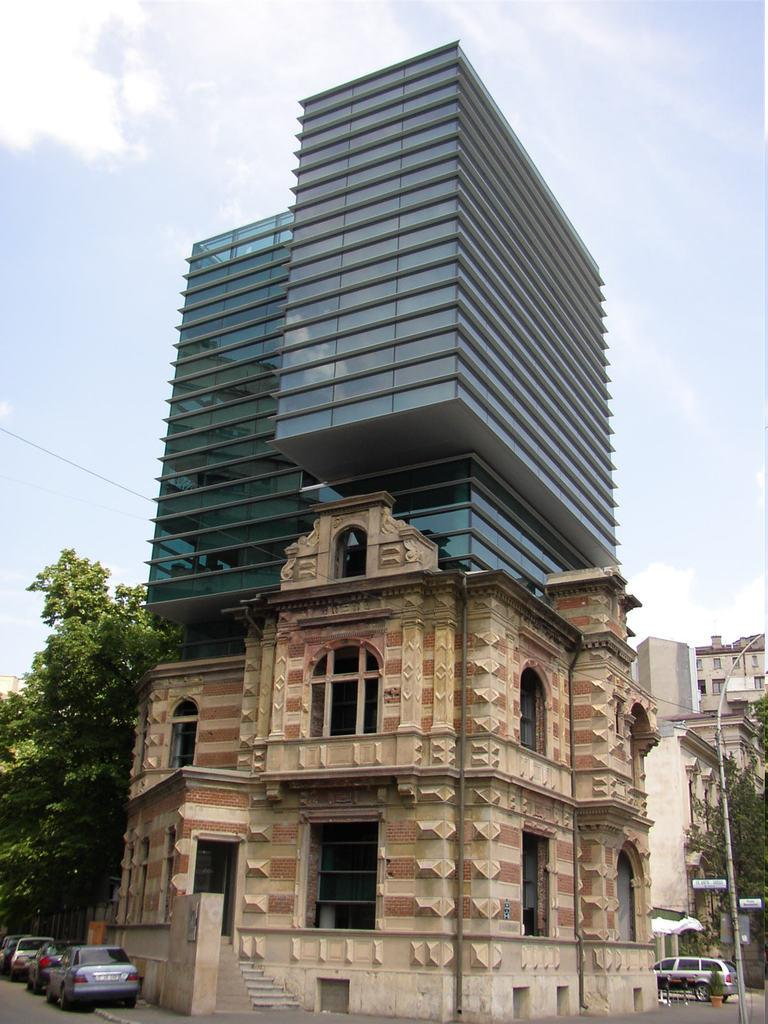What type of structures can be seen in the image? There are buildings in the image. What other natural elements are present in the image? There are trees in the image. What man-made objects can be seen in the image? There are vehicles and boards visible in the image. What is the tall, vertical object in the image? There is a pole in the image. What can be seen in the sky in the image? There are clouds visible in the sky. What type of square can be seen in the image? There is no square present in the image. What emotion is displayed by the disgust in the image? There is no emotion or disgust present in the image. 